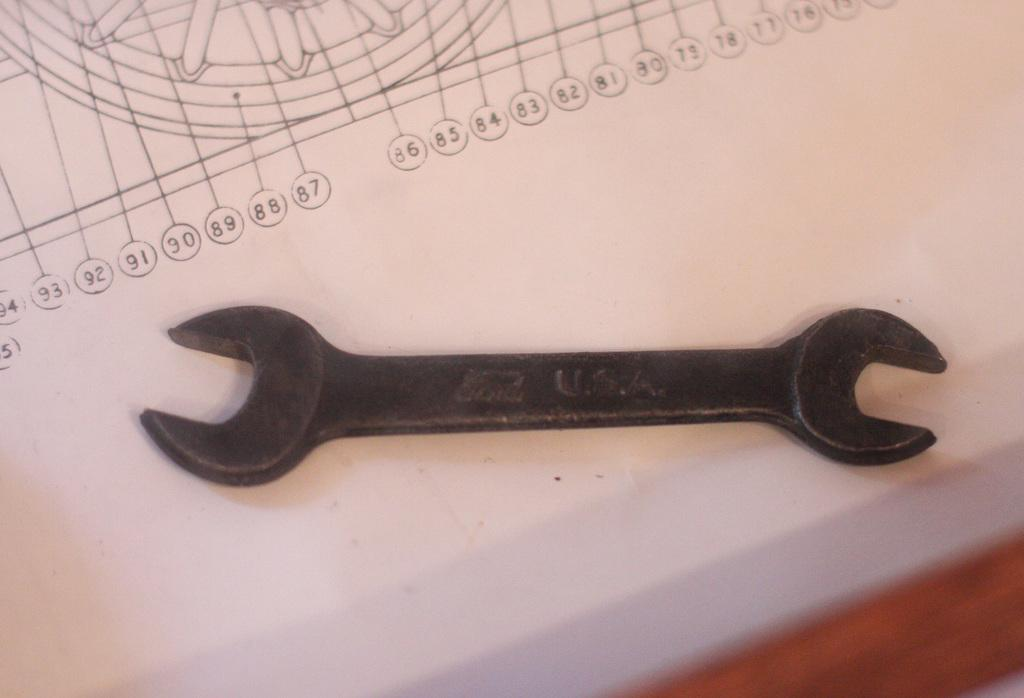What tool is visible in the image? There is a wrench in the image. Where is the wrench placed? The wrench is placed on a paper. What design can be seen in the image? There is a design of a wheel and numbers in the image. Where is the design located? The design is located at the top of the image. What piece of furniture is visible in the image? There is a table in the bottom right corner of the image. What type of government is depicted in the image? There is no depiction of a government in the image; it features a wrench, a paper, a design of a wheel and numbers, and a table. How does the rain affect the wrench in the image? There is no rain present in the image, so its effect on the wrench cannot be determined. 